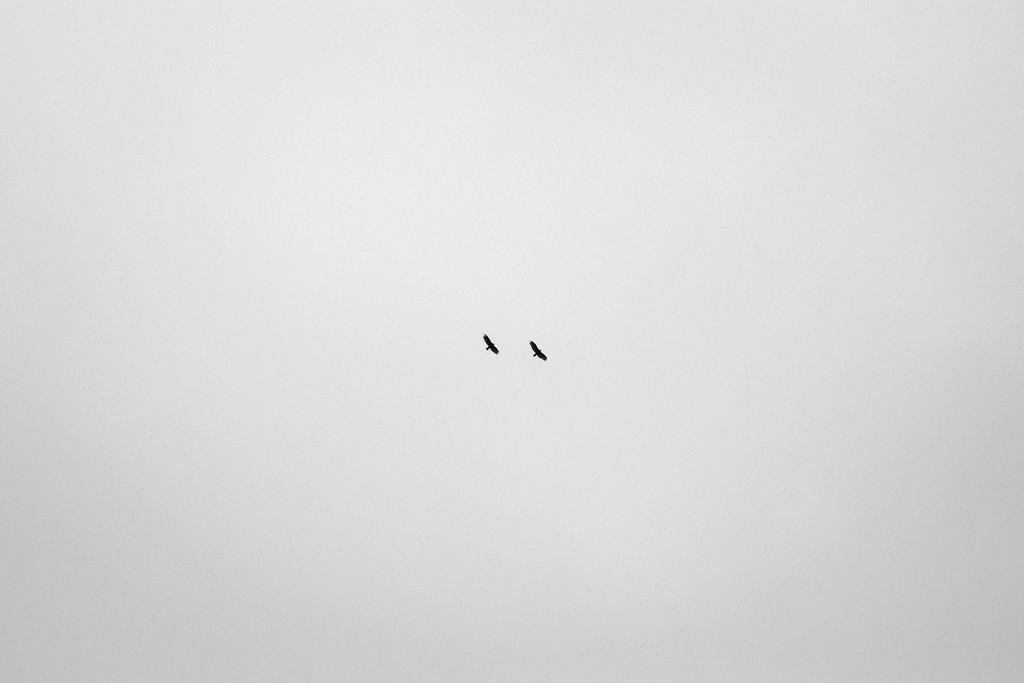How many birds are visible in the image? There are two birds in the image. What are the birds doing in the image? The birds are flying in the sky. What type of curtain can be seen hanging from the mountain in the image? There is no mountain or curtain present in the image; it features two birds flying in the sky. What is the birds using to write their answers in the image? There is no indication in the image that the birds are writing answers, as birds do not have the ability to write. 